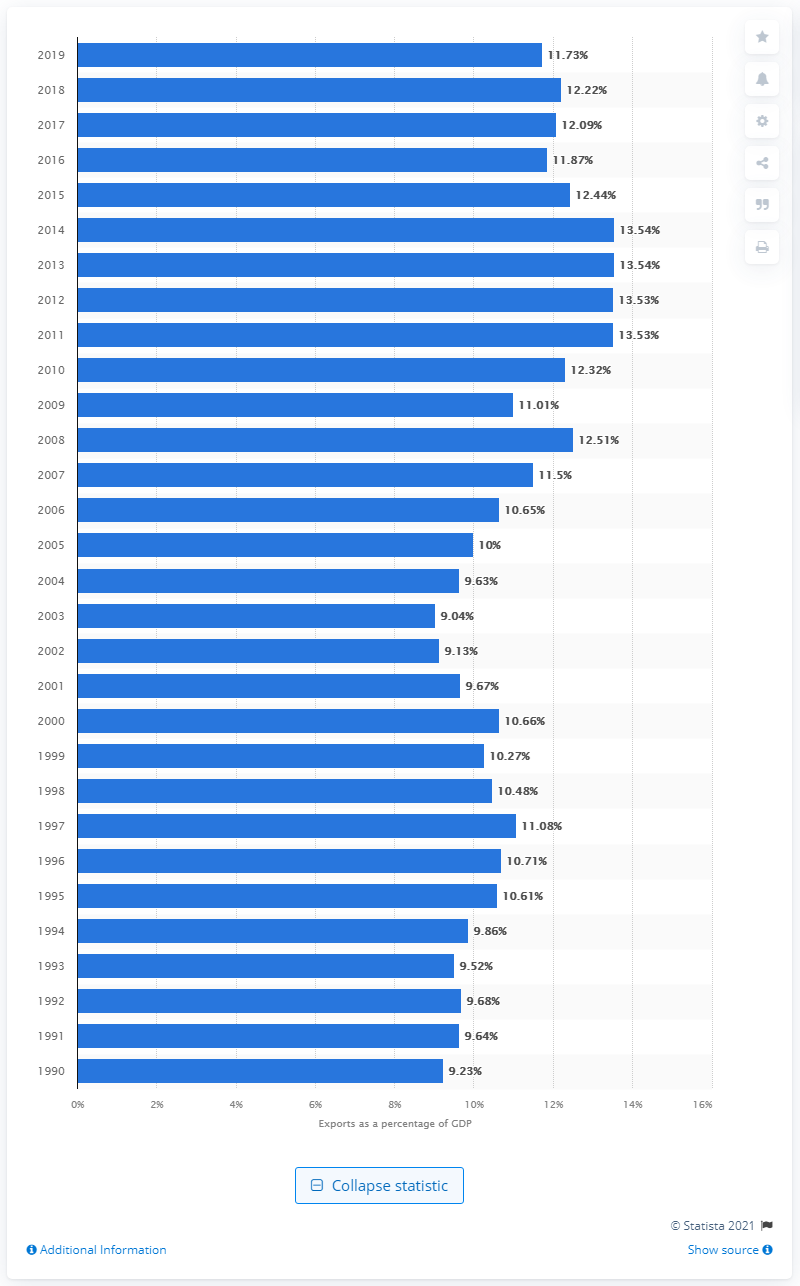Give some essential details in this illustration. In 1990, approximately 9.23% of the Gross Domestic Product (GDP) of the United States was exported. In 1990, the United States exported 9.23% of its Gross Domestic Product (GDP). 